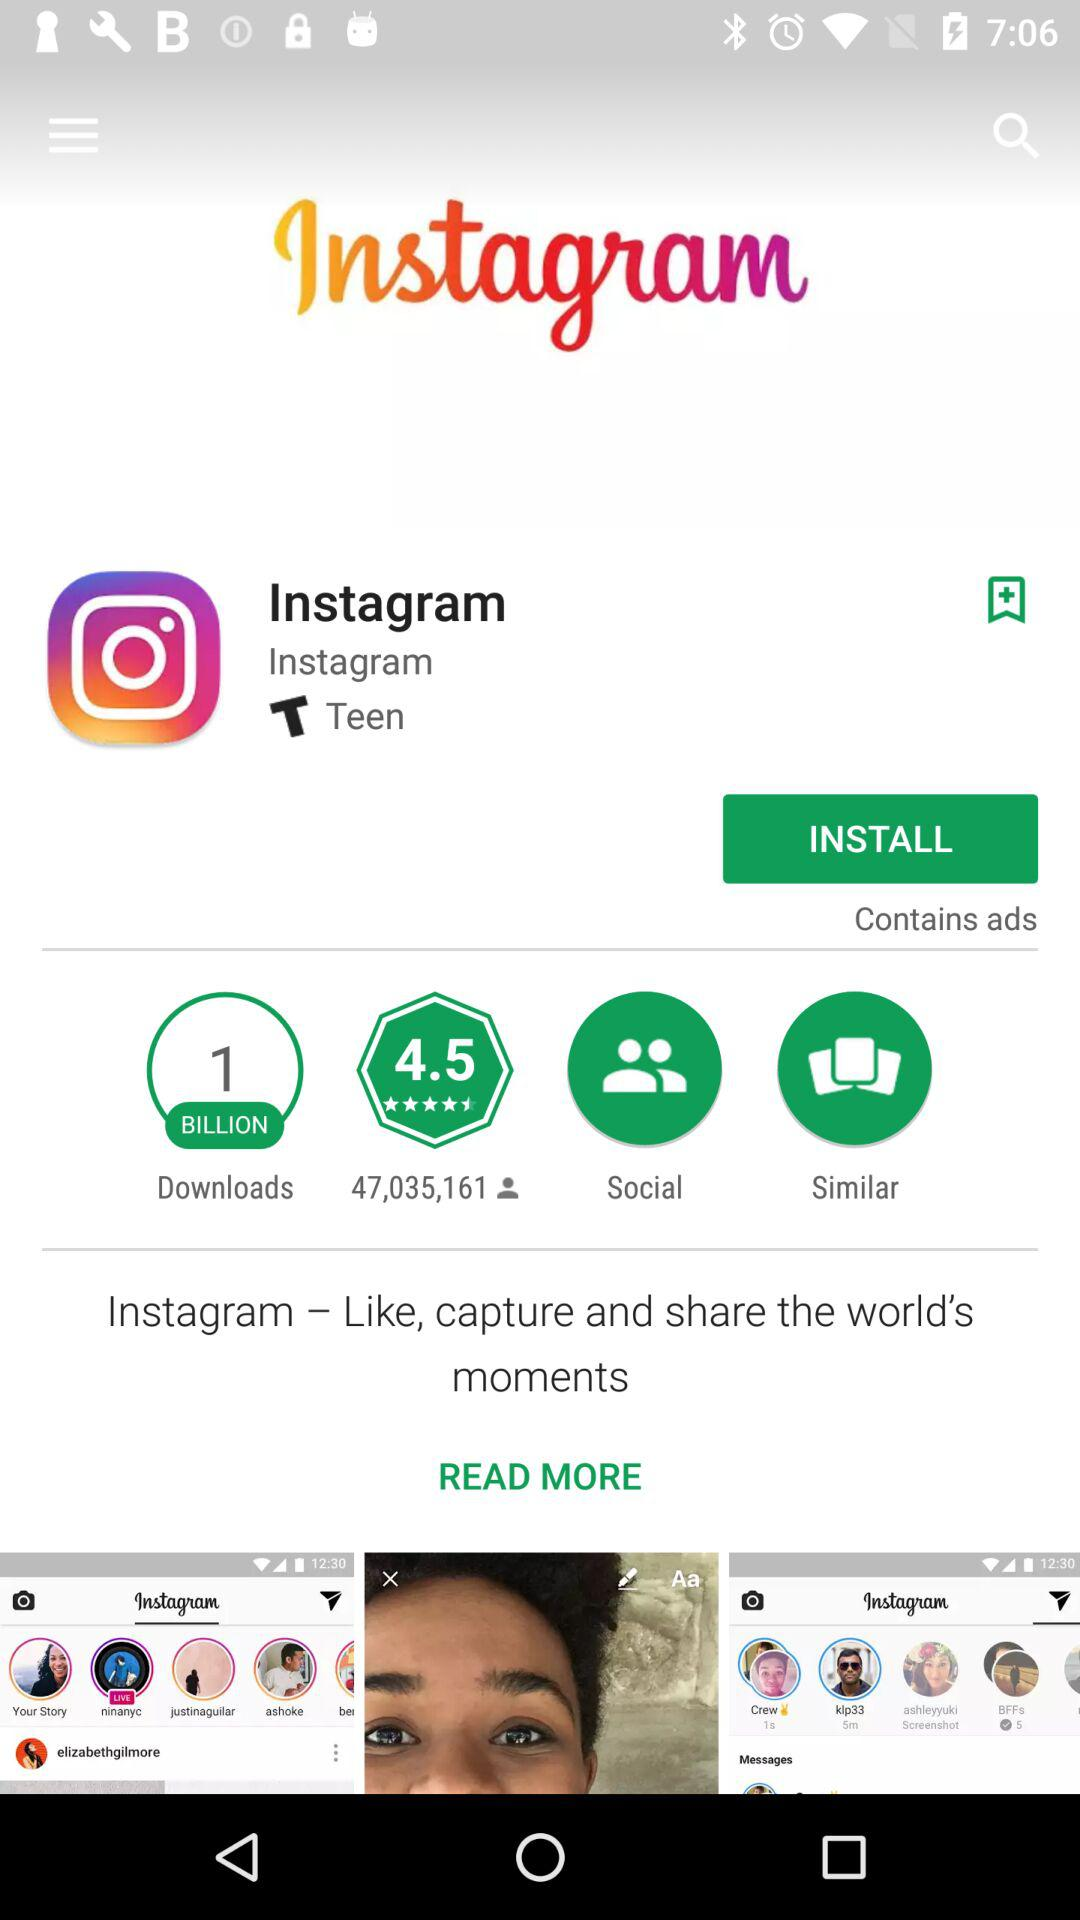How many people have rated the application? The number of people who have rated the application is 47,035,161. 